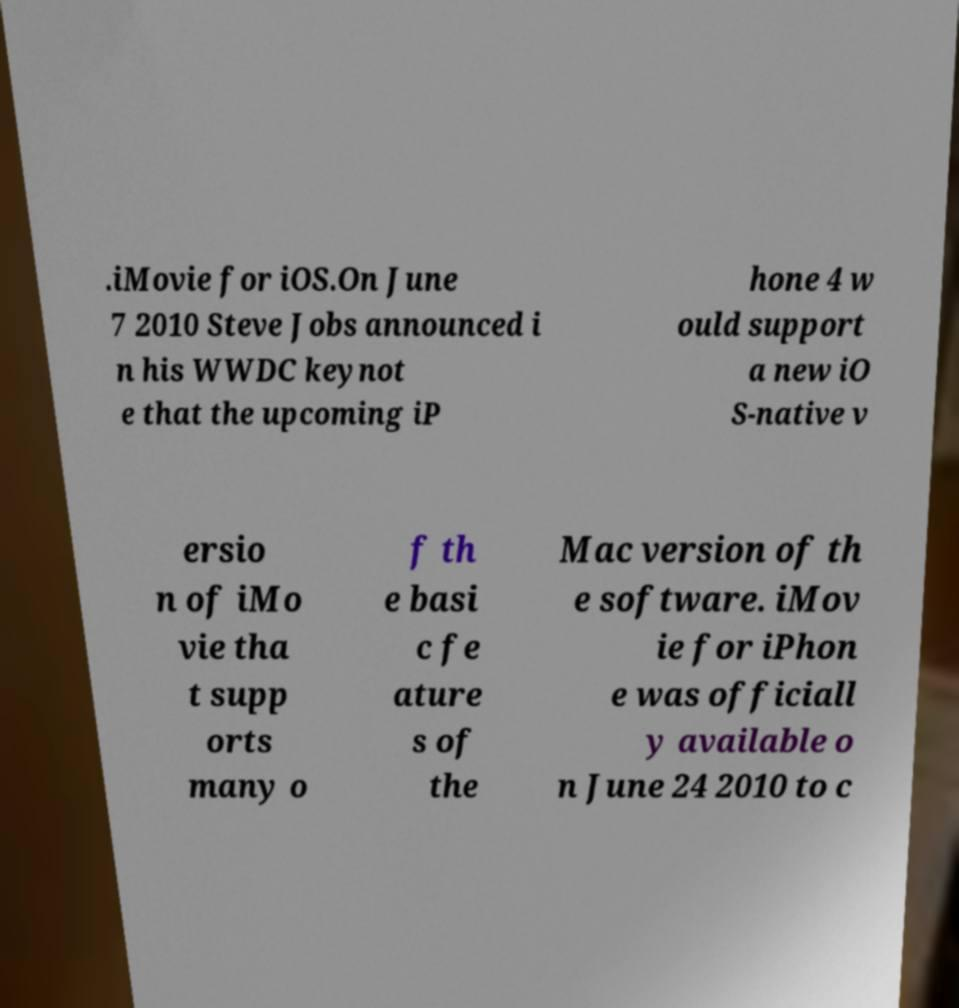Please identify and transcribe the text found in this image. .iMovie for iOS.On June 7 2010 Steve Jobs announced i n his WWDC keynot e that the upcoming iP hone 4 w ould support a new iO S-native v ersio n of iMo vie tha t supp orts many o f th e basi c fe ature s of the Mac version of th e software. iMov ie for iPhon e was officiall y available o n June 24 2010 to c 